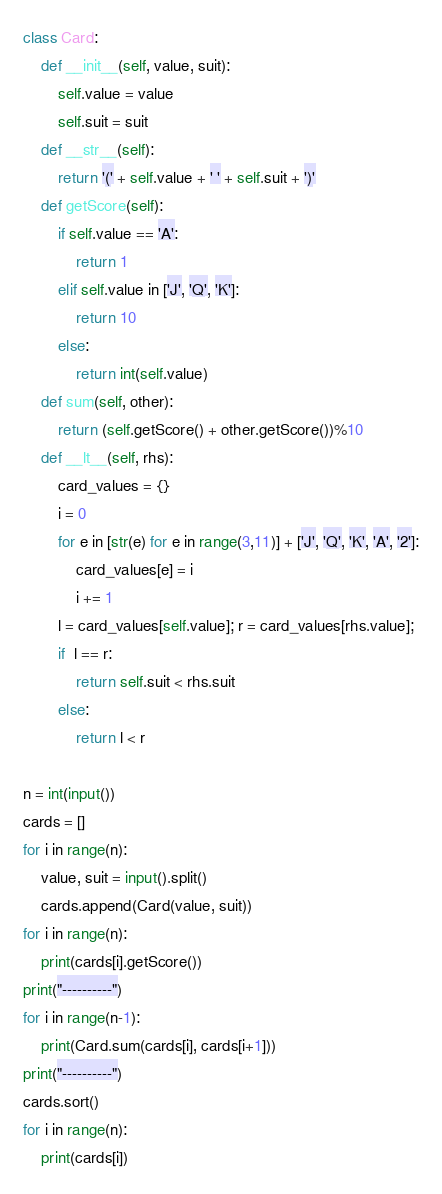Convert code to text. <code><loc_0><loc_0><loc_500><loc_500><_Python_>class Card:
    def __init__(self, value, suit):
        self.value = value
        self.suit = suit
    def __str__(self):
        return '(' + self.value + ' ' + self.suit + ')'
    def getScore(self):
        if self.value == 'A':
            return 1
        elif self.value in ['J', 'Q', 'K']:
            return 10
        else:
            return int(self.value)
    def sum(self, other):
        return (self.getScore() + other.getScore())%10
    def __lt__(self, rhs):
        card_values = {}
        i = 0
        for e in [str(e) for e in range(3,11)] + ['J', 'Q', 'K', 'A', '2']:
            card_values[e] = i
            i += 1
        l = card_values[self.value]; r = card_values[rhs.value];
        if  l == r:
            return self.suit < rhs.suit
        else:
            return l < r

n = int(input())
cards = []
for i in range(n):
    value, suit = input().split()
    cards.append(Card(value, suit))
for i in range(n):
    print(cards[i].getScore())
print("----------")
for i in range(n-1):
    print(Card.sum(cards[i], cards[i+1]))
print("----------")
cards.sort()
for i in range(n):
    print(cards[i])</code> 